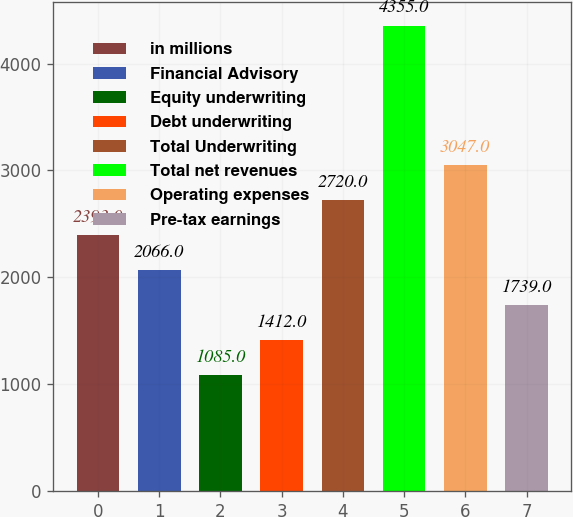Convert chart. <chart><loc_0><loc_0><loc_500><loc_500><bar_chart><fcel>in millions<fcel>Financial Advisory<fcel>Equity underwriting<fcel>Debt underwriting<fcel>Total Underwriting<fcel>Total net revenues<fcel>Operating expenses<fcel>Pre-tax earnings<nl><fcel>2393<fcel>2066<fcel>1085<fcel>1412<fcel>2720<fcel>4355<fcel>3047<fcel>1739<nl></chart> 